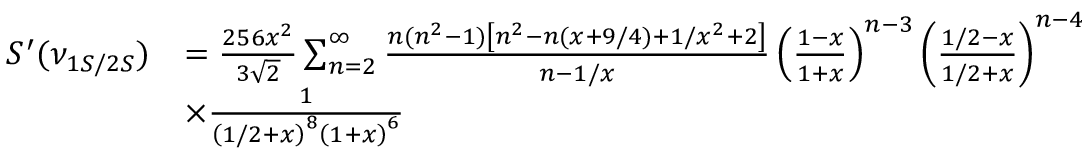Convert formula to latex. <formula><loc_0><loc_0><loc_500><loc_500>\begin{array} { r l } { S ^ { \prime } ( \nu _ { 1 S / 2 S } ) } & { = \frac { 2 5 6 x ^ { 2 } } { 3 \sqrt { 2 } } \sum _ { n = 2 } ^ { \infty } \frac { n ( n ^ { 2 } - 1 ) \left [ n ^ { 2 } - n ( x + 9 / 4 ) + 1 / x ^ { 2 } + 2 \right ] } { n - 1 / x } \left ( \frac { 1 - x } { 1 + x } \right ) ^ { n - 3 } \left ( \frac { 1 / 2 - x } { 1 / 2 + x } \right ) ^ { n - 4 } } \\ & { \times \frac { 1 } { \left ( 1 / 2 + x \right ) ^ { 8 } \left ( 1 + x \right ) ^ { 6 } } } \end{array}</formula> 